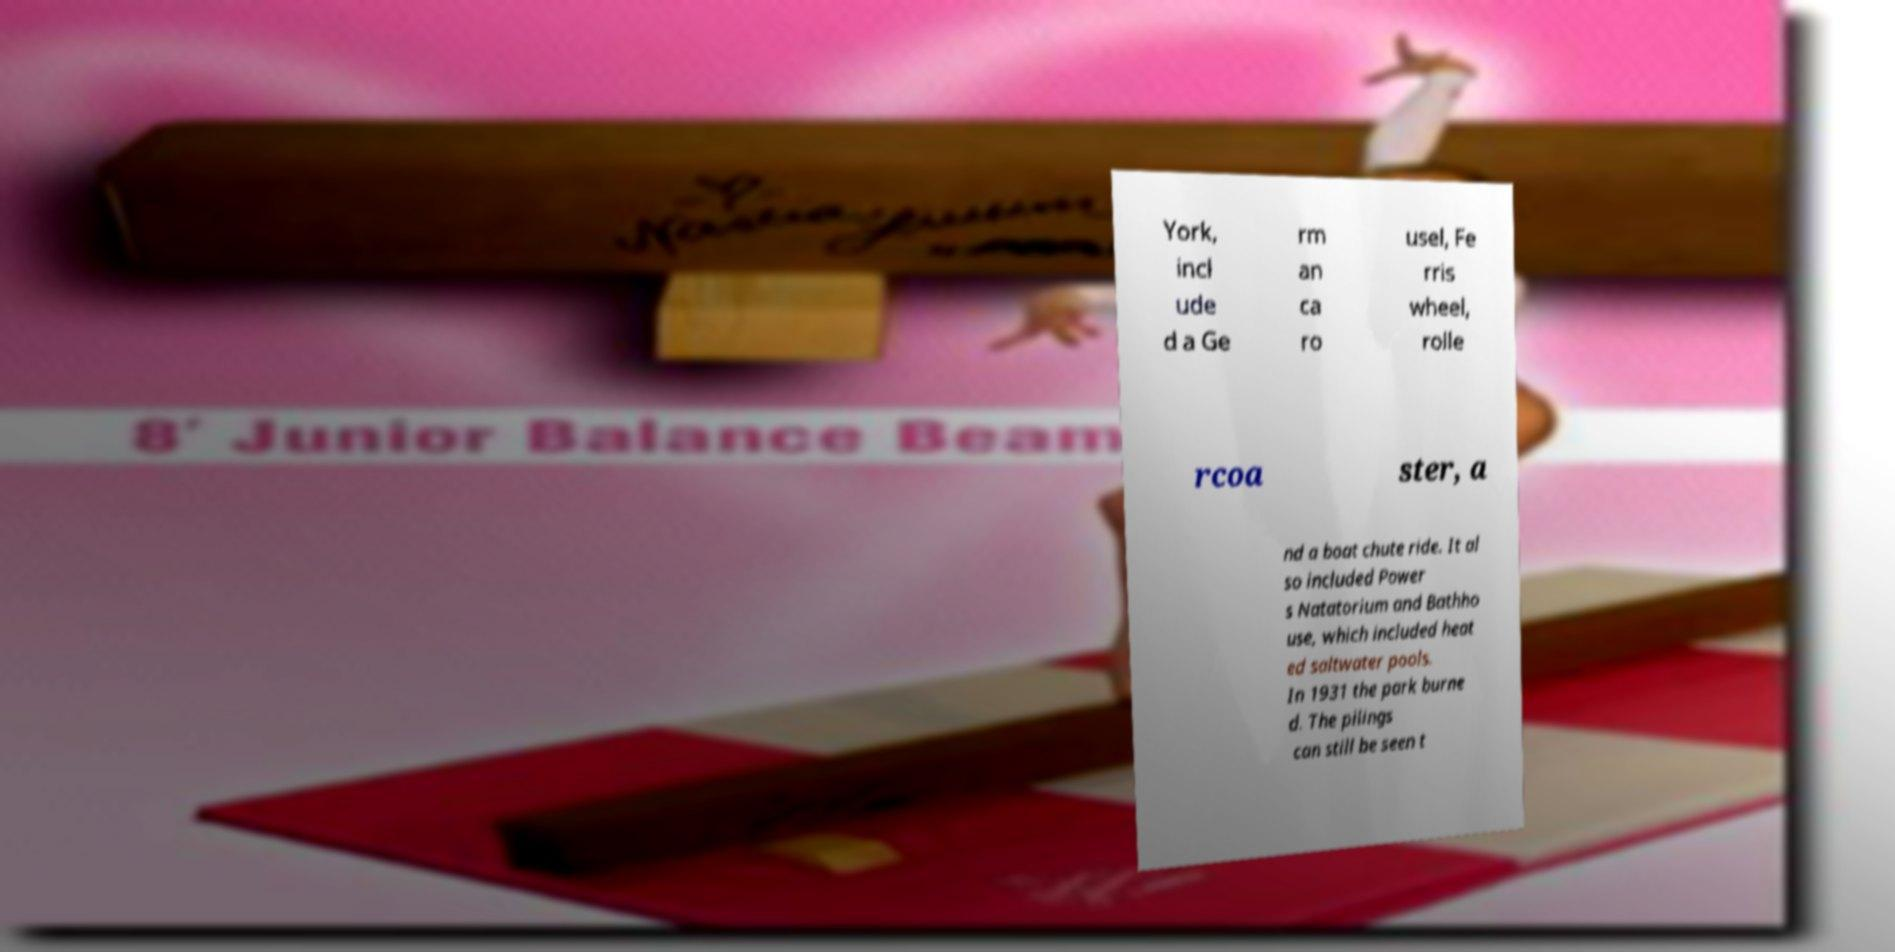Can you accurately transcribe the text from the provided image for me? York, incl ude d a Ge rm an ca ro usel, Fe rris wheel, rolle rcoa ster, a nd a boat chute ride. It al so included Power s Natatorium and Bathho use, which included heat ed saltwater pools. In 1931 the park burne d. The pilings can still be seen t 